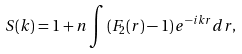<formula> <loc_0><loc_0><loc_500><loc_500>S ( k ) = 1 + n \int \left ( F _ { 2 } ( r ) - 1 \right ) e ^ { - i k r } d r ,</formula> 